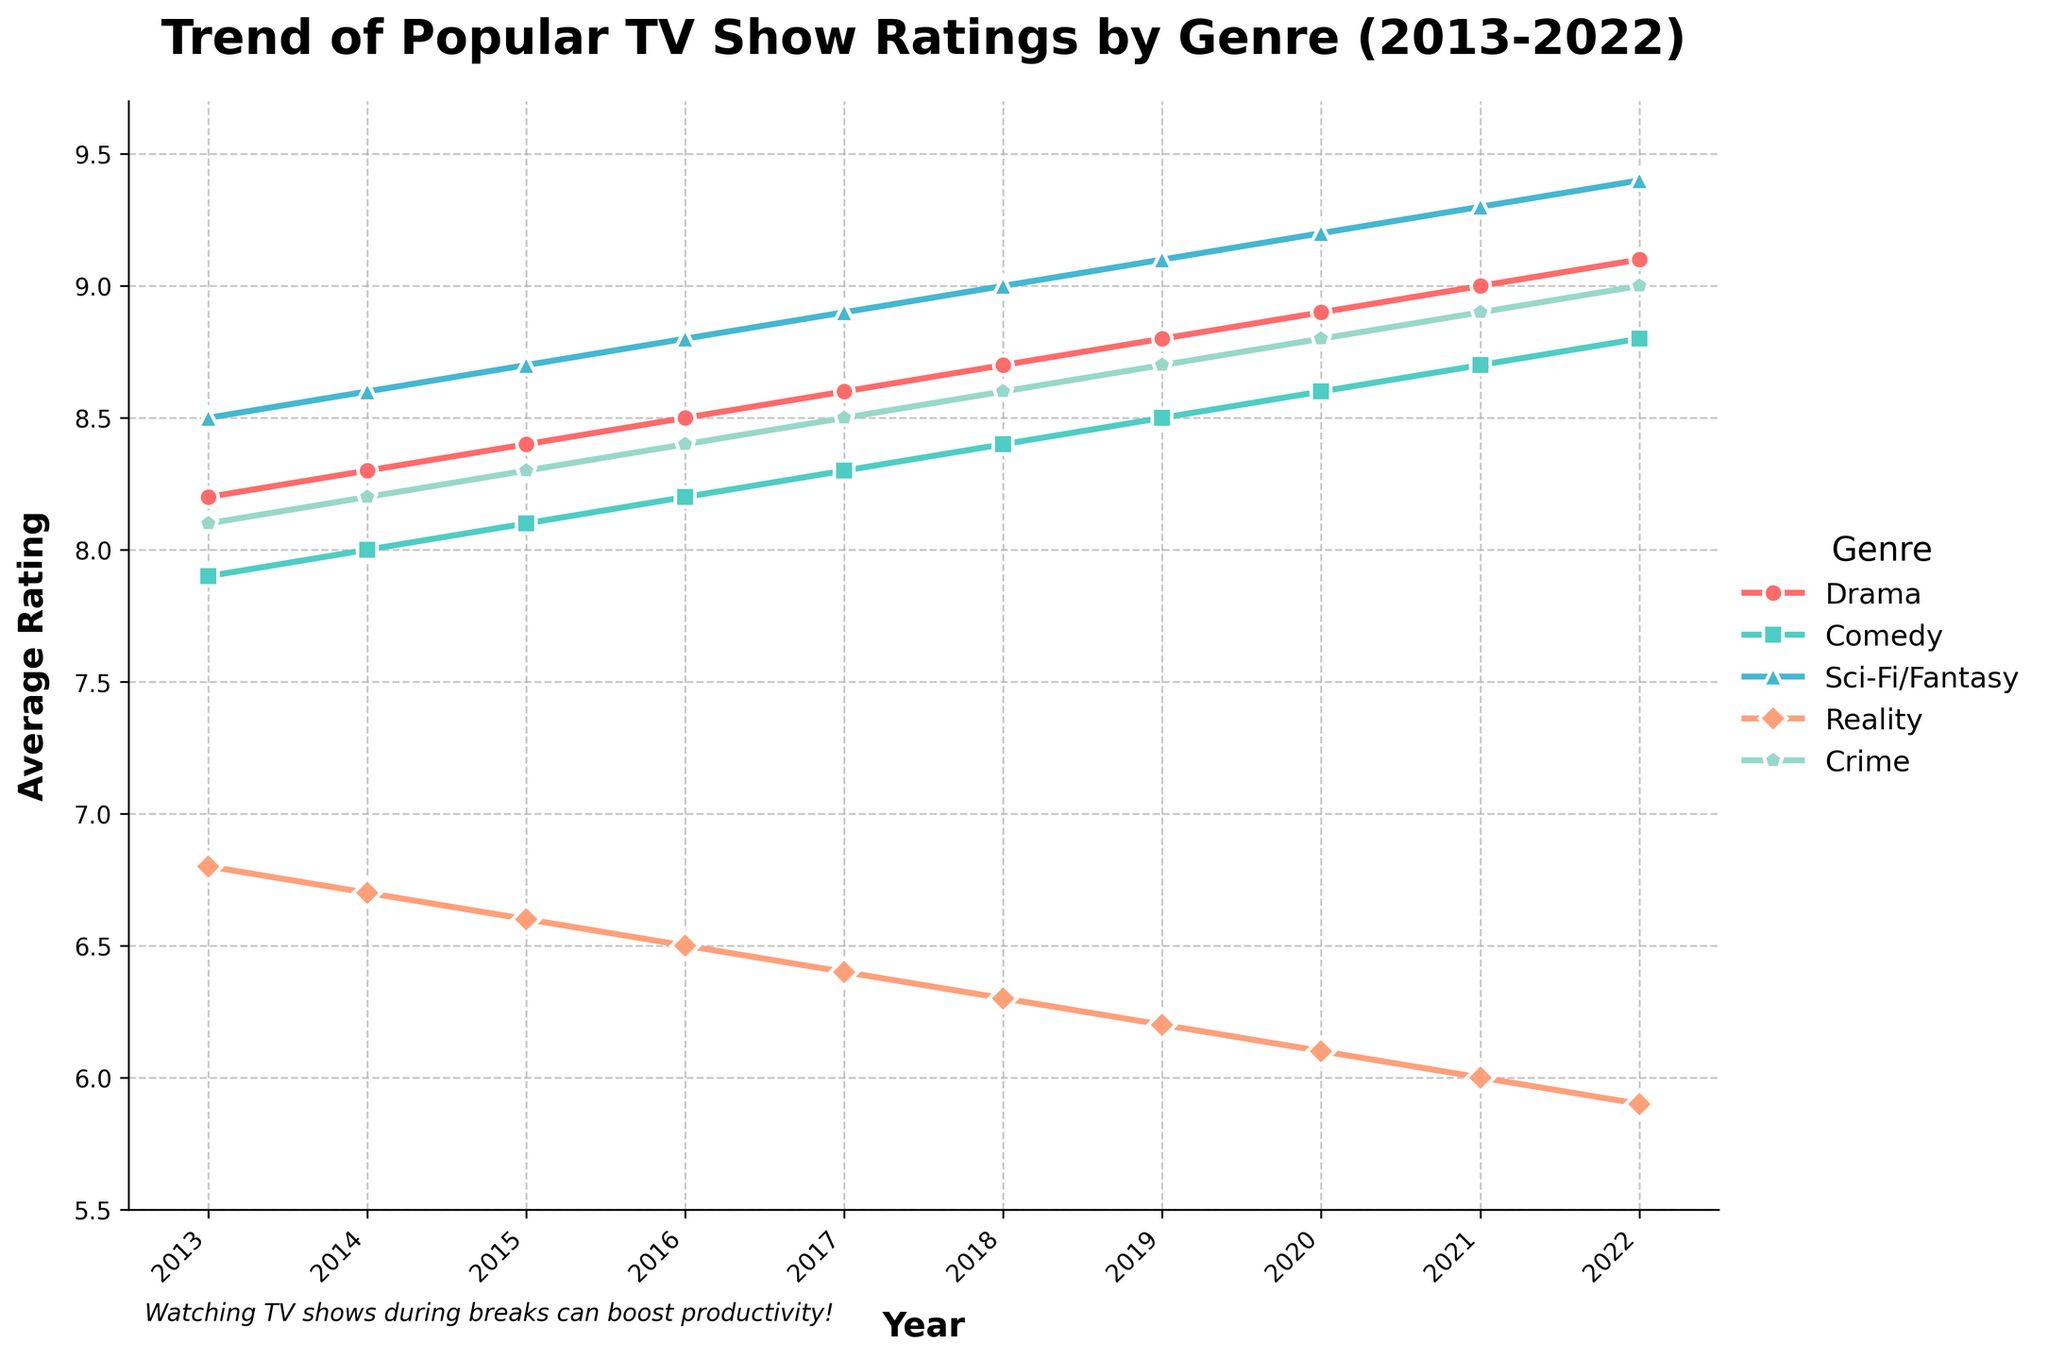What was the trend in the average ratings for the Drama genre from 2013 to 2022? The line representing the Drama genre shows an upward trend from 8.2 in 2013 to 9.1 in 2022, indicating a consistent increase in average ratings over the decade.
Answer: Upward trend Which genre had the highest average rating in 2019, and what was the value? In 2019, the Sci-Fi/Fantasy genre had the highest average rating, depicted by the peak of its line, which shows a value of 9.1.
Answer: Sci-Fi/Fantasy, 9.1 By how much did the average rating of Reality shows decrease from 2013 to 2022? The average rating for Reality shows was 6.8 in 2013 and decreased to 5.9 in 2022. The difference is calculated as 6.8 - 5.9 = 0.9.
Answer: 0.9 In which year did the Crime genre surpass an average rating of 8.5? The Crime genre surpassed an 8.5 rating in 2019, as shown by the line crossing the 8.5 mark between 2018 and 2019.
Answer: 2019 Compared to 2013, which genres showed at least a 1.0 increase in their average ratings by 2022? Drama increased from 8.2 to 9.1 (+0.9), Comedy from 7.9 to 8.8 (+0.9), Sci-Fi/Fantasy from 8.5 to 9.4 (+0.9), Reality from 6.8 to 5.9 (-0.9), and Crime from 8.1 to 9.0 (+0.9). Thus, Drama, Comedy, Sci-Fi/Fantasy, and Crime increased by at least 0.9.
Answer: Drama, Comedy, Sci-Fi/Fantasy, Crime Which genre had the Least improvement in average rating from 2013 to 2022? The Reality genre had the least improvement, actually showing a decrease from 6.8 in 2013 to 5.9 in 2022.
Answer: Reality What is the overall trend in ratings for the Comedy genre? The Comedy genre shows an upward trend from 7.9 in 2013 to 8.8 in 2022, indicating improving average ratings over the decade.
Answer: Upward trend How did the ratings for Sci-Fi/Fantasy change compared to Comedy in 2020? In 2020, the Sci-Fi/Fantasy genre had a higher rating of 9.2 compared to Comedy's rating of 8.6, indicating Sci-Fi/Fantasy was more popular based on average ratings.
Answer: Sci-Fi/Fantasy higher by 0.6 Which genre has shown the most consistent improvement in their ratings over the decade? The Drama genre shows the most consistent improvement, with its rating increasing steadily from 8.2 in 2013 to 9.1 in 2022 without any decreases.
Answer: Drama 